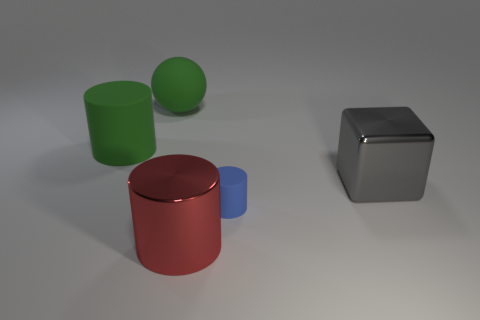Add 2 shiny blocks. How many objects exist? 7 Subtract all cubes. How many objects are left? 4 Subtract 0 brown spheres. How many objects are left? 5 Subtract all tiny yellow cubes. Subtract all tiny blue things. How many objects are left? 4 Add 1 blue objects. How many blue objects are left? 2 Add 2 small brown shiny balls. How many small brown shiny balls exist? 2 